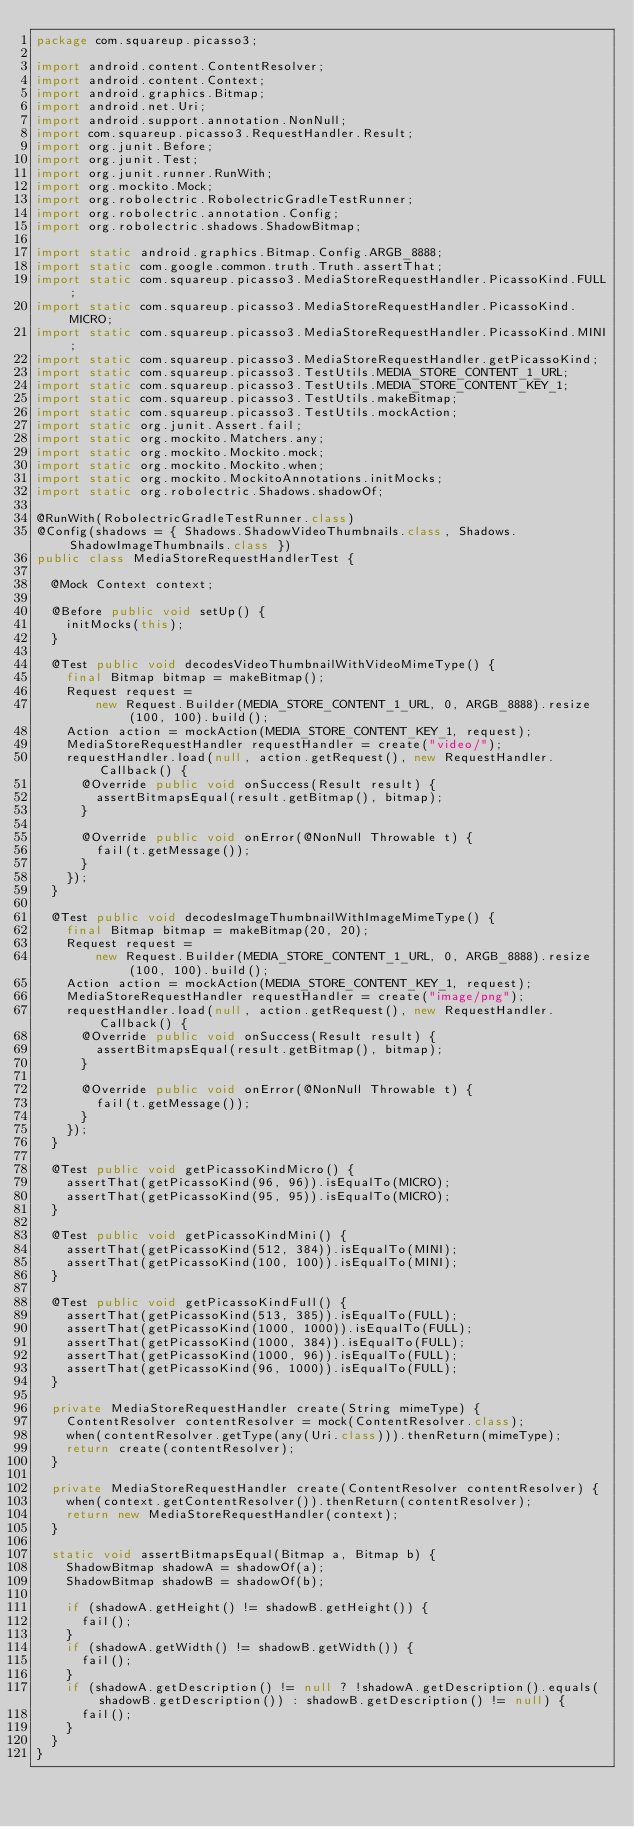<code> <loc_0><loc_0><loc_500><loc_500><_Java_>package com.squareup.picasso3;

import android.content.ContentResolver;
import android.content.Context;
import android.graphics.Bitmap;
import android.net.Uri;
import android.support.annotation.NonNull;
import com.squareup.picasso3.RequestHandler.Result;
import org.junit.Before;
import org.junit.Test;
import org.junit.runner.RunWith;
import org.mockito.Mock;
import org.robolectric.RobolectricGradleTestRunner;
import org.robolectric.annotation.Config;
import org.robolectric.shadows.ShadowBitmap;

import static android.graphics.Bitmap.Config.ARGB_8888;
import static com.google.common.truth.Truth.assertThat;
import static com.squareup.picasso3.MediaStoreRequestHandler.PicassoKind.FULL;
import static com.squareup.picasso3.MediaStoreRequestHandler.PicassoKind.MICRO;
import static com.squareup.picasso3.MediaStoreRequestHandler.PicassoKind.MINI;
import static com.squareup.picasso3.MediaStoreRequestHandler.getPicassoKind;
import static com.squareup.picasso3.TestUtils.MEDIA_STORE_CONTENT_1_URL;
import static com.squareup.picasso3.TestUtils.MEDIA_STORE_CONTENT_KEY_1;
import static com.squareup.picasso3.TestUtils.makeBitmap;
import static com.squareup.picasso3.TestUtils.mockAction;
import static org.junit.Assert.fail;
import static org.mockito.Matchers.any;
import static org.mockito.Mockito.mock;
import static org.mockito.Mockito.when;
import static org.mockito.MockitoAnnotations.initMocks;
import static org.robolectric.Shadows.shadowOf;

@RunWith(RobolectricGradleTestRunner.class)
@Config(shadows = { Shadows.ShadowVideoThumbnails.class, Shadows.ShadowImageThumbnails.class })
public class MediaStoreRequestHandlerTest {

  @Mock Context context;

  @Before public void setUp() {
    initMocks(this);
  }

  @Test public void decodesVideoThumbnailWithVideoMimeType() {
    final Bitmap bitmap = makeBitmap();
    Request request =
        new Request.Builder(MEDIA_STORE_CONTENT_1_URL, 0, ARGB_8888).resize(100, 100).build();
    Action action = mockAction(MEDIA_STORE_CONTENT_KEY_1, request);
    MediaStoreRequestHandler requestHandler = create("video/");
    requestHandler.load(null, action.getRequest(), new RequestHandler.Callback() {
      @Override public void onSuccess(Result result) {
        assertBitmapsEqual(result.getBitmap(), bitmap);
      }

      @Override public void onError(@NonNull Throwable t) {
        fail(t.getMessage());
      }
    });
  }

  @Test public void decodesImageThumbnailWithImageMimeType() {
    final Bitmap bitmap = makeBitmap(20, 20);
    Request request =
        new Request.Builder(MEDIA_STORE_CONTENT_1_URL, 0, ARGB_8888).resize(100, 100).build();
    Action action = mockAction(MEDIA_STORE_CONTENT_KEY_1, request);
    MediaStoreRequestHandler requestHandler = create("image/png");
    requestHandler.load(null, action.getRequest(), new RequestHandler.Callback() {
      @Override public void onSuccess(Result result) {
        assertBitmapsEqual(result.getBitmap(), bitmap);
      }

      @Override public void onError(@NonNull Throwable t) {
        fail(t.getMessage());
      }
    });
  }

  @Test public void getPicassoKindMicro() {
    assertThat(getPicassoKind(96, 96)).isEqualTo(MICRO);
    assertThat(getPicassoKind(95, 95)).isEqualTo(MICRO);
  }

  @Test public void getPicassoKindMini() {
    assertThat(getPicassoKind(512, 384)).isEqualTo(MINI);
    assertThat(getPicassoKind(100, 100)).isEqualTo(MINI);
  }

  @Test public void getPicassoKindFull() {
    assertThat(getPicassoKind(513, 385)).isEqualTo(FULL);
    assertThat(getPicassoKind(1000, 1000)).isEqualTo(FULL);
    assertThat(getPicassoKind(1000, 384)).isEqualTo(FULL);
    assertThat(getPicassoKind(1000, 96)).isEqualTo(FULL);
    assertThat(getPicassoKind(96, 1000)).isEqualTo(FULL);
  }

  private MediaStoreRequestHandler create(String mimeType) {
    ContentResolver contentResolver = mock(ContentResolver.class);
    when(contentResolver.getType(any(Uri.class))).thenReturn(mimeType);
    return create(contentResolver);
  }

  private MediaStoreRequestHandler create(ContentResolver contentResolver) {
    when(context.getContentResolver()).thenReturn(contentResolver);
    return new MediaStoreRequestHandler(context);
  }

  static void assertBitmapsEqual(Bitmap a, Bitmap b) {
    ShadowBitmap shadowA = shadowOf(a);
    ShadowBitmap shadowB = shadowOf(b);

    if (shadowA.getHeight() != shadowB.getHeight()) {
      fail();
    }
    if (shadowA.getWidth() != shadowB.getWidth()) {
      fail();
    }
    if (shadowA.getDescription() != null ? !shadowA.getDescription().equals(shadowB.getDescription()) : shadowB.getDescription() != null) {
      fail();
    }
  }
}
</code> 